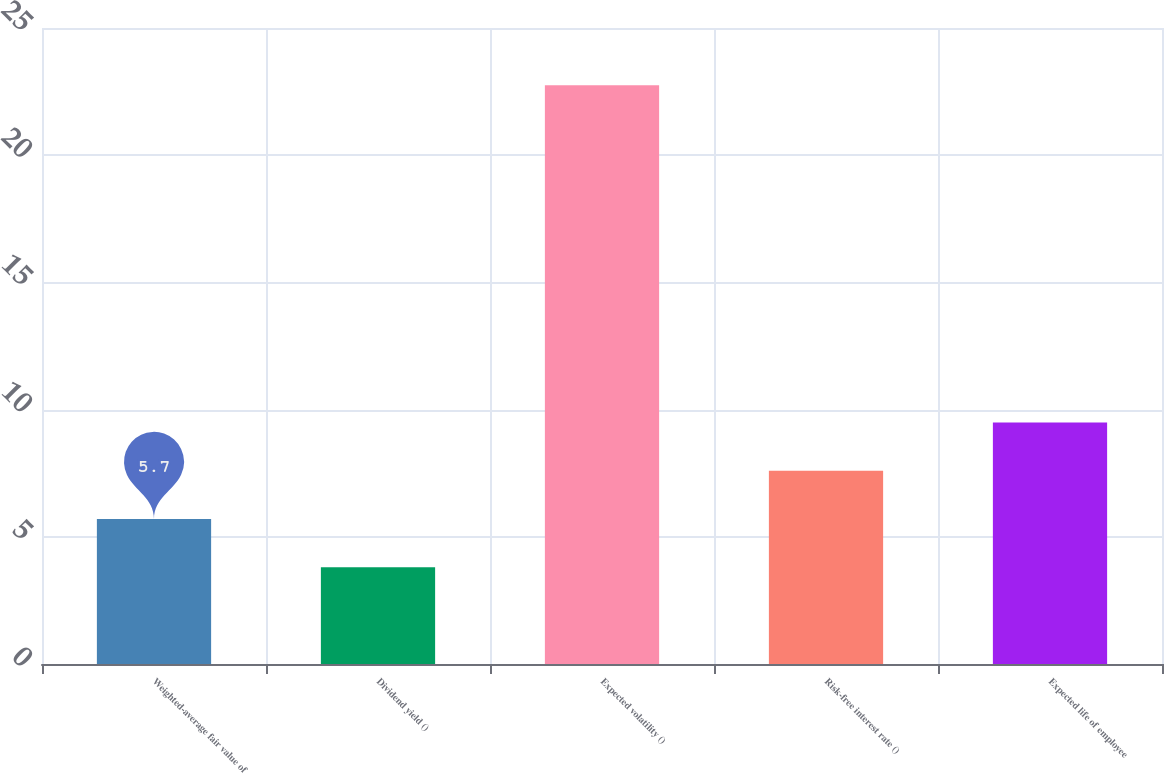<chart> <loc_0><loc_0><loc_500><loc_500><bar_chart><fcel>Weighted-average fair value of<fcel>Dividend yield ()<fcel>Expected volatility ()<fcel>Risk-free interest rate ()<fcel>Expected life of employee<nl><fcel>5.7<fcel>3.8<fcel>22.75<fcel>7.6<fcel>9.49<nl></chart> 